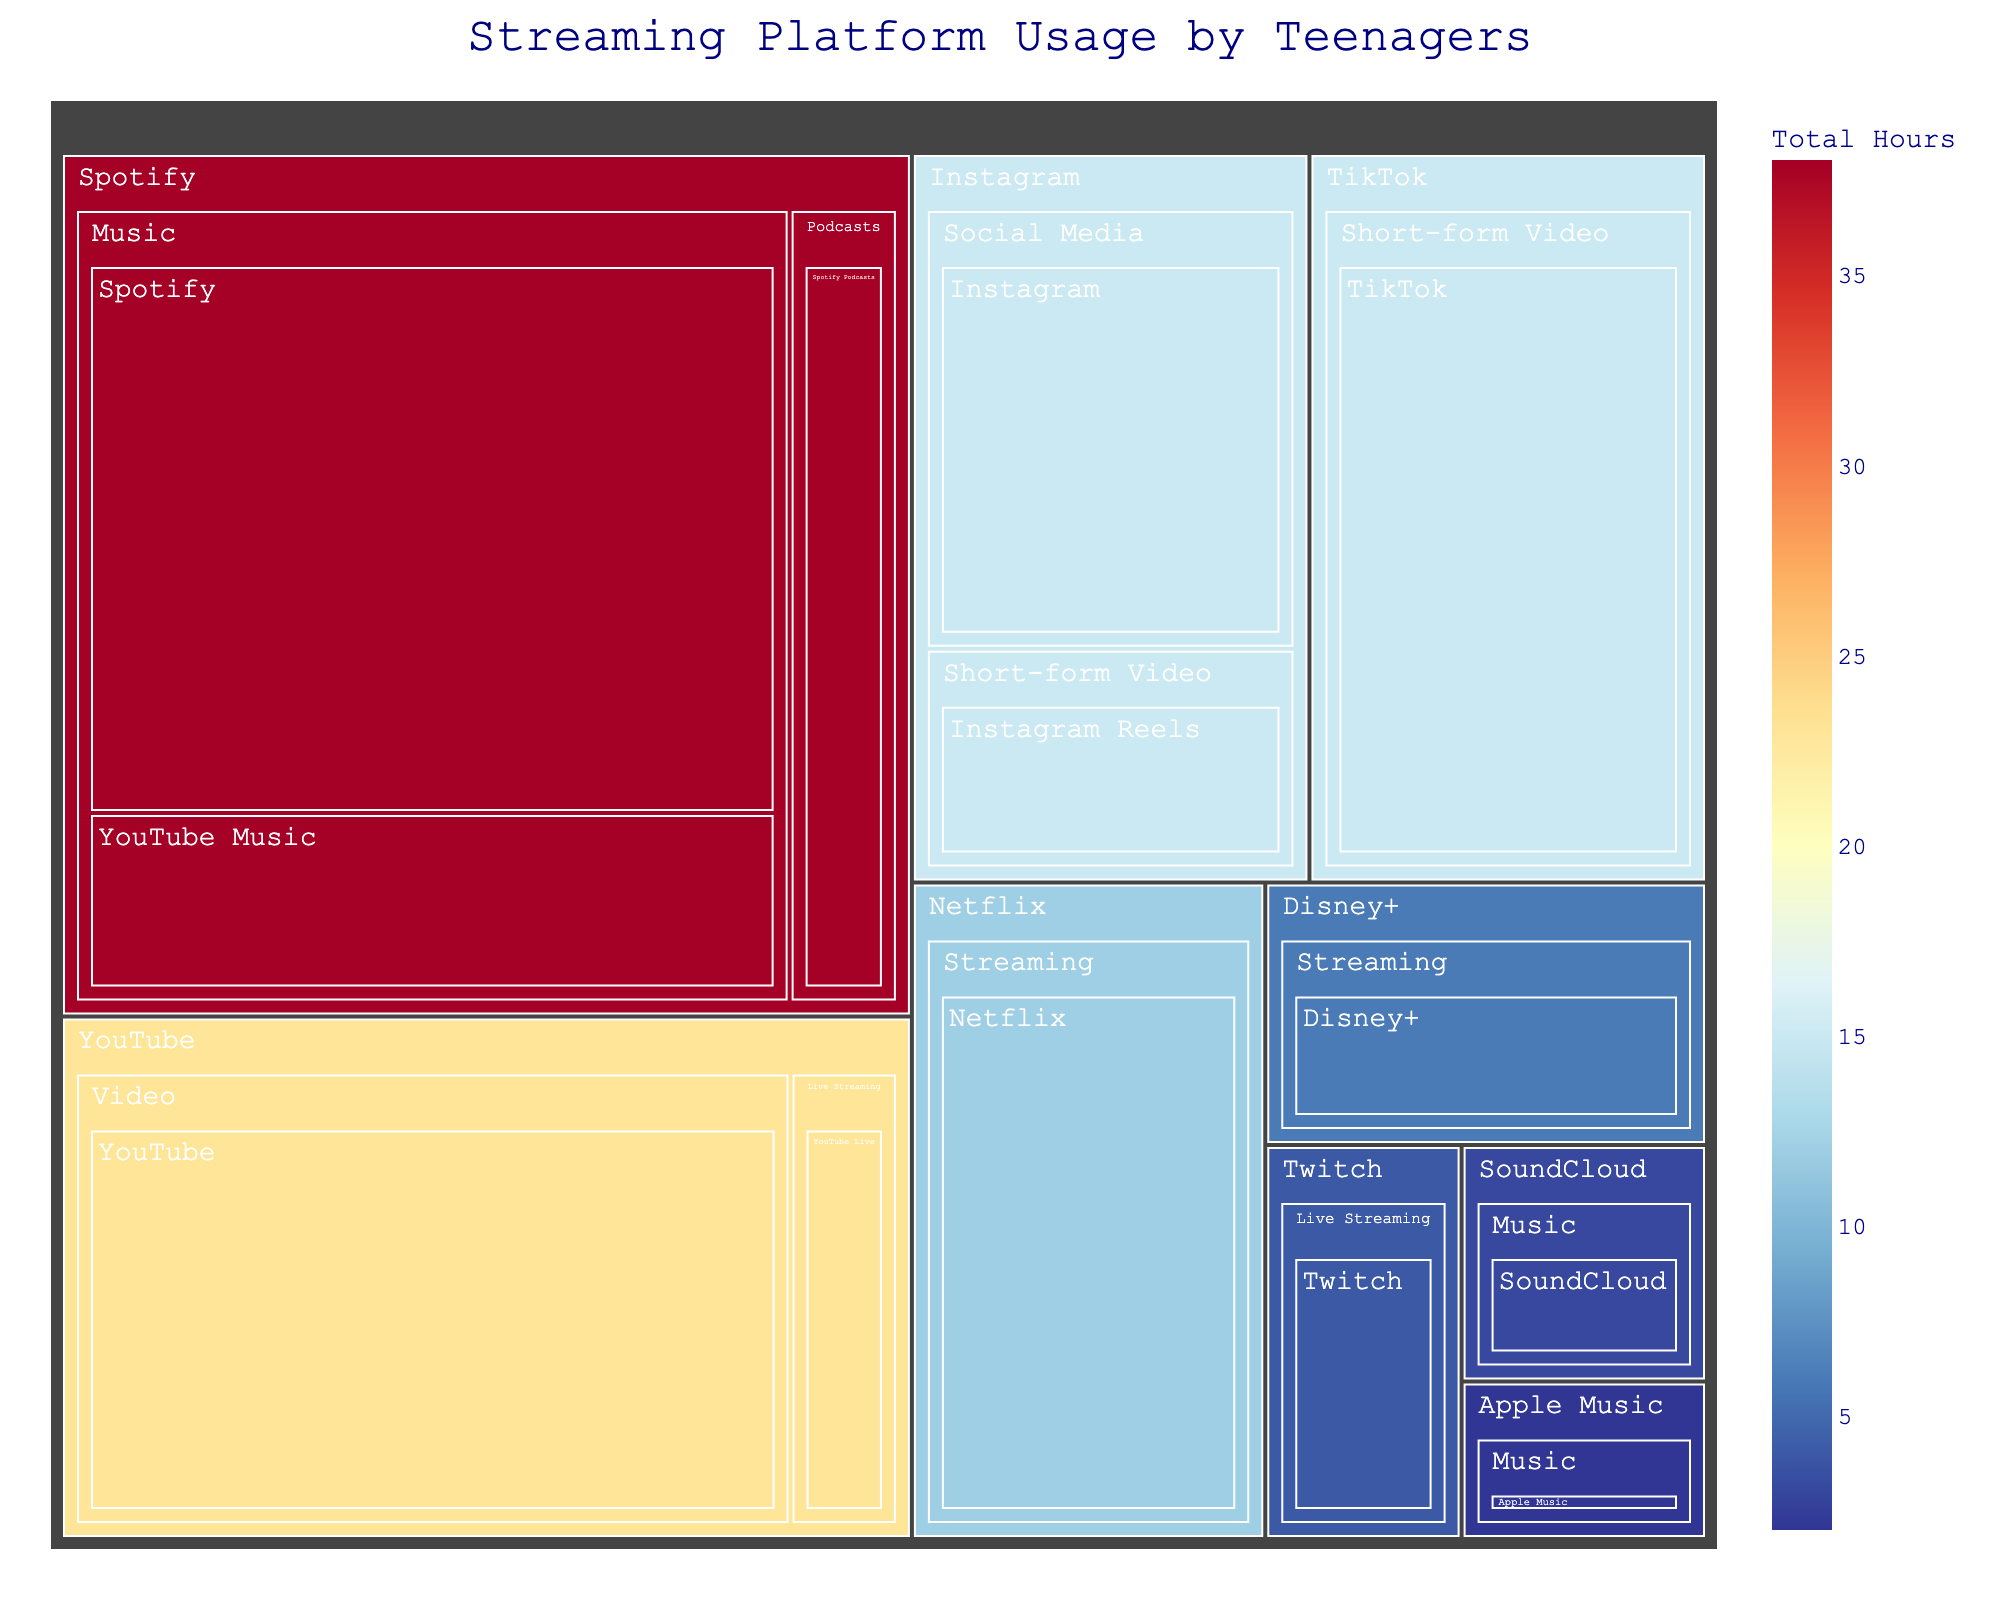What's the title of the treemap? The title is usually displayed at the top of the figure in a larger or bold font to indicate what the figure is about.
Answer: Streaming Platform Usage by Teenagers Which app under the "Music" category in the "Spotify" platform has the highest usage time? Under the "Spotify" platform and "Music" category, the largest section represents the app with the highest usage time.
Answer: Spotify What's the total number of hours spent on the "YouTube" platform? Add up all the hours spent on the apps under the "YouTube" platform by looking at the sum of the sizes or the hover data on the treemap for each app.
Answer: 23 How many hours more are spent on "TikTok" compared to "Instagram Reels"? Locate the hours spent on "TikTok" and "Instagram Reels" in their respective sections of the treemap and subtract the hours spent on Instagram Reels from those on TikTok.
Answer: 10 hours Which platform has the lowest total usage time, and what is it? Identify the platform with the smallest summed section or the lightest color and check its total hours.
Answer: Apple Music, 2 hours List the apps used under the "Streaming" category with their respective hours. Locate the "Streaming" category branch and list each app within it, along with the hours displayed.
Answer: Netflix: 12, Disney+: 6 Compare the hours spent on "Live Streaming" between "YouTube" and "Twitch". Which platform has higher usage? Look at the sections under the "Live Streaming" category for "YouTube" and "Twitch", and compare the hours.
Answer: YouTube What is the combined total time spent on "Short-form Video" apps? Add the hours for "TikTok" and "Instagram Reels" by identifying these apps under their respective "Short-form Video" categories.
Answer: 20 hours Which app has more hours: "YouTube" or "Spotify Podcasts"? Compare the sections representing "YouTube" and "Spotify Podcasts" in the treemap and note their hours.
Answer: YouTube 